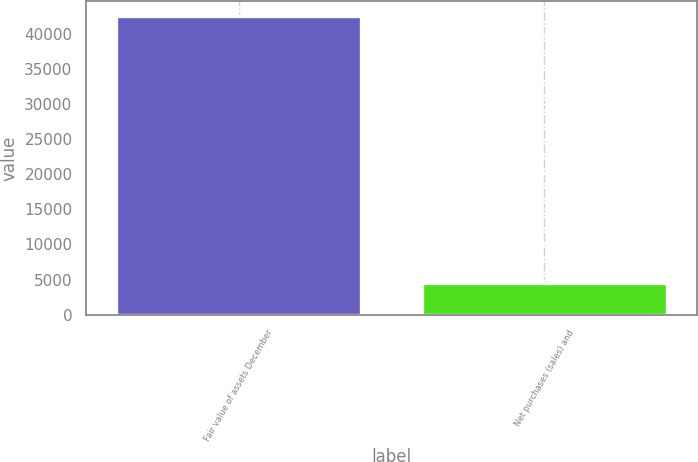Convert chart. <chart><loc_0><loc_0><loc_500><loc_500><bar_chart><fcel>Fair value of assets December<fcel>Net purchases (sales) and<nl><fcel>42547.8<fcel>4523<nl></chart> 